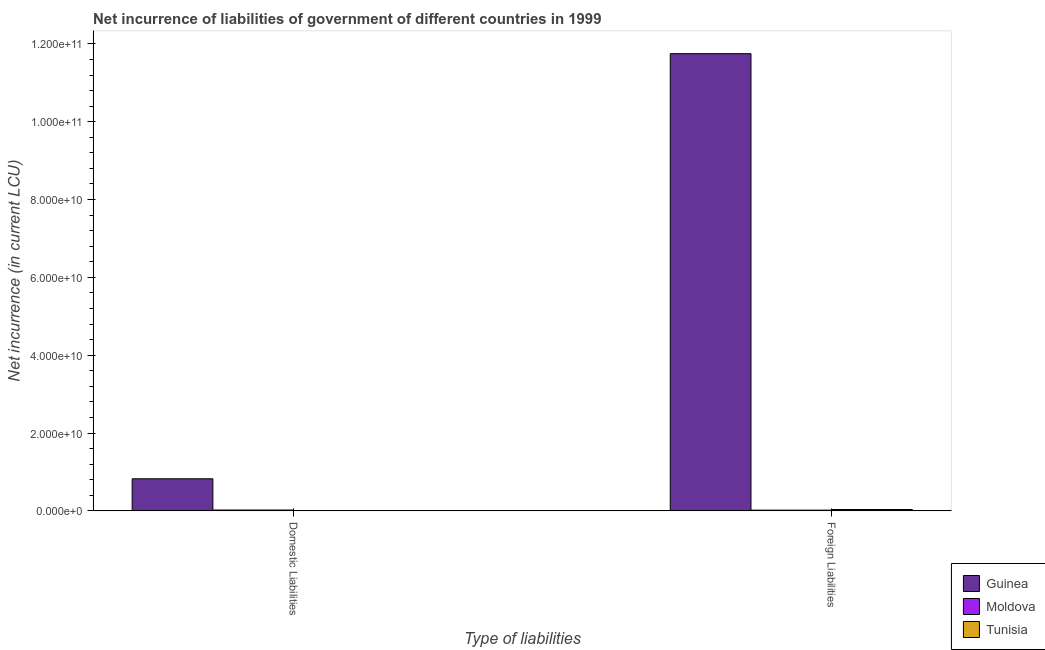How many bars are there on the 2nd tick from the right?
Offer a terse response. 3. What is the label of the 1st group of bars from the left?
Offer a very short reply. Domestic Liabilities. What is the net incurrence of domestic liabilities in Tunisia?
Your answer should be very brief. 9.00e+07. Across all countries, what is the maximum net incurrence of foreign liabilities?
Ensure brevity in your answer.  1.17e+11. Across all countries, what is the minimum net incurrence of foreign liabilities?
Give a very brief answer. 1.96e+08. In which country was the net incurrence of foreign liabilities maximum?
Make the answer very short. Guinea. In which country was the net incurrence of foreign liabilities minimum?
Your answer should be very brief. Moldova. What is the total net incurrence of domestic liabilities in the graph?
Provide a short and direct response. 8.56e+09. What is the difference between the net incurrence of foreign liabilities in Tunisia and that in Moldova?
Your answer should be very brief. 1.54e+08. What is the difference between the net incurrence of domestic liabilities in Guinea and the net incurrence of foreign liabilities in Moldova?
Give a very brief answer. 8.05e+09. What is the average net incurrence of domestic liabilities per country?
Provide a short and direct response. 2.85e+09. What is the difference between the net incurrence of foreign liabilities and net incurrence of domestic liabilities in Moldova?
Offer a terse response. -2.85e+07. In how many countries, is the net incurrence of domestic liabilities greater than 72000000000 LCU?
Offer a terse response. 0. What is the ratio of the net incurrence of foreign liabilities in Moldova to that in Tunisia?
Make the answer very short. 0.56. Is the net incurrence of domestic liabilities in Tunisia less than that in Moldova?
Your answer should be very brief. Yes. In how many countries, is the net incurrence of domestic liabilities greater than the average net incurrence of domestic liabilities taken over all countries?
Offer a terse response. 1. What does the 1st bar from the left in Foreign Liabilities represents?
Provide a succinct answer. Guinea. What does the 2nd bar from the right in Domestic Liabilities represents?
Keep it short and to the point. Moldova. How many countries are there in the graph?
Your response must be concise. 3. Where does the legend appear in the graph?
Give a very brief answer. Bottom right. How many legend labels are there?
Keep it short and to the point. 3. How are the legend labels stacked?
Your response must be concise. Vertical. What is the title of the graph?
Keep it short and to the point. Net incurrence of liabilities of government of different countries in 1999. What is the label or title of the X-axis?
Keep it short and to the point. Type of liabilities. What is the label or title of the Y-axis?
Keep it short and to the point. Net incurrence (in current LCU). What is the Net incurrence (in current LCU) in Guinea in Domestic Liabilities?
Your answer should be very brief. 8.25e+09. What is the Net incurrence (in current LCU) in Moldova in Domestic Liabilities?
Your response must be concise. 2.24e+08. What is the Net incurrence (in current LCU) of Tunisia in Domestic Liabilities?
Give a very brief answer. 9.00e+07. What is the Net incurrence (in current LCU) of Guinea in Foreign Liabilities?
Keep it short and to the point. 1.17e+11. What is the Net incurrence (in current LCU) in Moldova in Foreign Liabilities?
Your answer should be compact. 1.96e+08. What is the Net incurrence (in current LCU) in Tunisia in Foreign Liabilities?
Provide a short and direct response. 3.50e+08. Across all Type of liabilities, what is the maximum Net incurrence (in current LCU) of Guinea?
Offer a terse response. 1.17e+11. Across all Type of liabilities, what is the maximum Net incurrence (in current LCU) of Moldova?
Your answer should be compact. 2.24e+08. Across all Type of liabilities, what is the maximum Net incurrence (in current LCU) in Tunisia?
Make the answer very short. 3.50e+08. Across all Type of liabilities, what is the minimum Net incurrence (in current LCU) in Guinea?
Offer a terse response. 8.25e+09. Across all Type of liabilities, what is the minimum Net incurrence (in current LCU) of Moldova?
Keep it short and to the point. 1.96e+08. Across all Type of liabilities, what is the minimum Net incurrence (in current LCU) of Tunisia?
Ensure brevity in your answer.  9.00e+07. What is the total Net incurrence (in current LCU) of Guinea in the graph?
Make the answer very short. 1.26e+11. What is the total Net incurrence (in current LCU) of Moldova in the graph?
Offer a terse response. 4.20e+08. What is the total Net incurrence (in current LCU) of Tunisia in the graph?
Keep it short and to the point. 4.40e+08. What is the difference between the Net incurrence (in current LCU) of Guinea in Domestic Liabilities and that in Foreign Liabilities?
Your response must be concise. -1.09e+11. What is the difference between the Net incurrence (in current LCU) of Moldova in Domestic Liabilities and that in Foreign Liabilities?
Make the answer very short. 2.85e+07. What is the difference between the Net incurrence (in current LCU) of Tunisia in Domestic Liabilities and that in Foreign Liabilities?
Your answer should be very brief. -2.60e+08. What is the difference between the Net incurrence (in current LCU) in Guinea in Domestic Liabilities and the Net incurrence (in current LCU) in Moldova in Foreign Liabilities?
Provide a short and direct response. 8.05e+09. What is the difference between the Net incurrence (in current LCU) in Guinea in Domestic Liabilities and the Net incurrence (in current LCU) in Tunisia in Foreign Liabilities?
Give a very brief answer. 7.90e+09. What is the difference between the Net incurrence (in current LCU) in Moldova in Domestic Liabilities and the Net incurrence (in current LCU) in Tunisia in Foreign Liabilities?
Give a very brief answer. -1.25e+08. What is the average Net incurrence (in current LCU) of Guinea per Type of liabilities?
Offer a terse response. 6.29e+1. What is the average Net incurrence (in current LCU) in Moldova per Type of liabilities?
Provide a short and direct response. 2.10e+08. What is the average Net incurrence (in current LCU) of Tunisia per Type of liabilities?
Make the answer very short. 2.20e+08. What is the difference between the Net incurrence (in current LCU) of Guinea and Net incurrence (in current LCU) of Moldova in Domestic Liabilities?
Ensure brevity in your answer.  8.03e+09. What is the difference between the Net incurrence (in current LCU) of Guinea and Net incurrence (in current LCU) of Tunisia in Domestic Liabilities?
Provide a short and direct response. 8.16e+09. What is the difference between the Net incurrence (in current LCU) of Moldova and Net incurrence (in current LCU) of Tunisia in Domestic Liabilities?
Your answer should be very brief. 1.34e+08. What is the difference between the Net incurrence (in current LCU) in Guinea and Net incurrence (in current LCU) in Moldova in Foreign Liabilities?
Make the answer very short. 1.17e+11. What is the difference between the Net incurrence (in current LCU) of Guinea and Net incurrence (in current LCU) of Tunisia in Foreign Liabilities?
Make the answer very short. 1.17e+11. What is the difference between the Net incurrence (in current LCU) of Moldova and Net incurrence (in current LCU) of Tunisia in Foreign Liabilities?
Give a very brief answer. -1.54e+08. What is the ratio of the Net incurrence (in current LCU) of Guinea in Domestic Liabilities to that in Foreign Liabilities?
Your answer should be compact. 0.07. What is the ratio of the Net incurrence (in current LCU) in Moldova in Domestic Liabilities to that in Foreign Liabilities?
Give a very brief answer. 1.15. What is the ratio of the Net incurrence (in current LCU) of Tunisia in Domestic Liabilities to that in Foreign Liabilities?
Your answer should be very brief. 0.26. What is the difference between the highest and the second highest Net incurrence (in current LCU) in Guinea?
Offer a very short reply. 1.09e+11. What is the difference between the highest and the second highest Net incurrence (in current LCU) of Moldova?
Make the answer very short. 2.85e+07. What is the difference between the highest and the second highest Net incurrence (in current LCU) of Tunisia?
Provide a short and direct response. 2.60e+08. What is the difference between the highest and the lowest Net incurrence (in current LCU) in Guinea?
Your answer should be very brief. 1.09e+11. What is the difference between the highest and the lowest Net incurrence (in current LCU) in Moldova?
Provide a succinct answer. 2.85e+07. What is the difference between the highest and the lowest Net incurrence (in current LCU) of Tunisia?
Keep it short and to the point. 2.60e+08. 